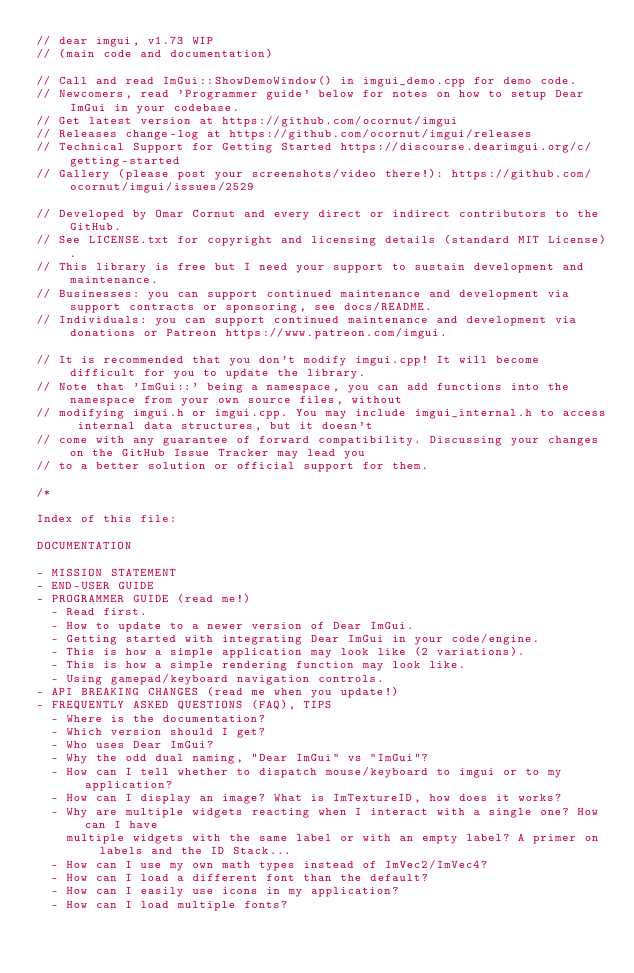Convert code to text. <code><loc_0><loc_0><loc_500><loc_500><_C++_>// dear imgui, v1.73 WIP
// (main code and documentation)

// Call and read ImGui::ShowDemoWindow() in imgui_demo.cpp for demo code.
// Newcomers, read 'Programmer guide' below for notes on how to setup Dear ImGui in your codebase.
// Get latest version at https://github.com/ocornut/imgui
// Releases change-log at https://github.com/ocornut/imgui/releases
// Technical Support for Getting Started https://discourse.dearimgui.org/c/getting-started
// Gallery (please post your screenshots/video there!): https://github.com/ocornut/imgui/issues/2529

// Developed by Omar Cornut and every direct or indirect contributors to the GitHub.
// See LICENSE.txt for copyright and licensing details (standard MIT License).
// This library is free but I need your support to sustain development and maintenance.
// Businesses: you can support continued maintenance and development via support contracts or sponsoring, see docs/README.
// Individuals: you can support continued maintenance and development via donations or Patreon https://www.patreon.com/imgui.

// It is recommended that you don't modify imgui.cpp! It will become difficult for you to update the library.
// Note that 'ImGui::' being a namespace, you can add functions into the namespace from your own source files, without
// modifying imgui.h or imgui.cpp. You may include imgui_internal.h to access internal data structures, but it doesn't
// come with any guarantee of forward compatibility. Discussing your changes on the GitHub Issue Tracker may lead you
// to a better solution or official support for them.

/*

Index of this file:

DOCUMENTATION

- MISSION STATEMENT
- END-USER GUIDE
- PROGRAMMER GUIDE (read me!)
  - Read first.
  - How to update to a newer version of Dear ImGui.
  - Getting started with integrating Dear ImGui in your code/engine.
  - This is how a simple application may look like (2 variations).
  - This is how a simple rendering function may look like.
  - Using gamepad/keyboard navigation controls.
- API BREAKING CHANGES (read me when you update!)
- FREQUENTLY ASKED QUESTIONS (FAQ), TIPS
  - Where is the documentation?
  - Which version should I get?
  - Who uses Dear ImGui?
  - Why the odd dual naming, "Dear ImGui" vs "ImGui"?
  - How can I tell whether to dispatch mouse/keyboard to imgui or to my application?
  - How can I display an image? What is ImTextureID, how does it works?
  - Why are multiple widgets reacting when I interact with a single one? How can I have
    multiple widgets with the same label or with an empty label? A primer on labels and the ID Stack...
  - How can I use my own math types instead of ImVec2/ImVec4?
  - How can I load a different font than the default?
  - How can I easily use icons in my application?
  - How can I load multiple fonts?</code> 